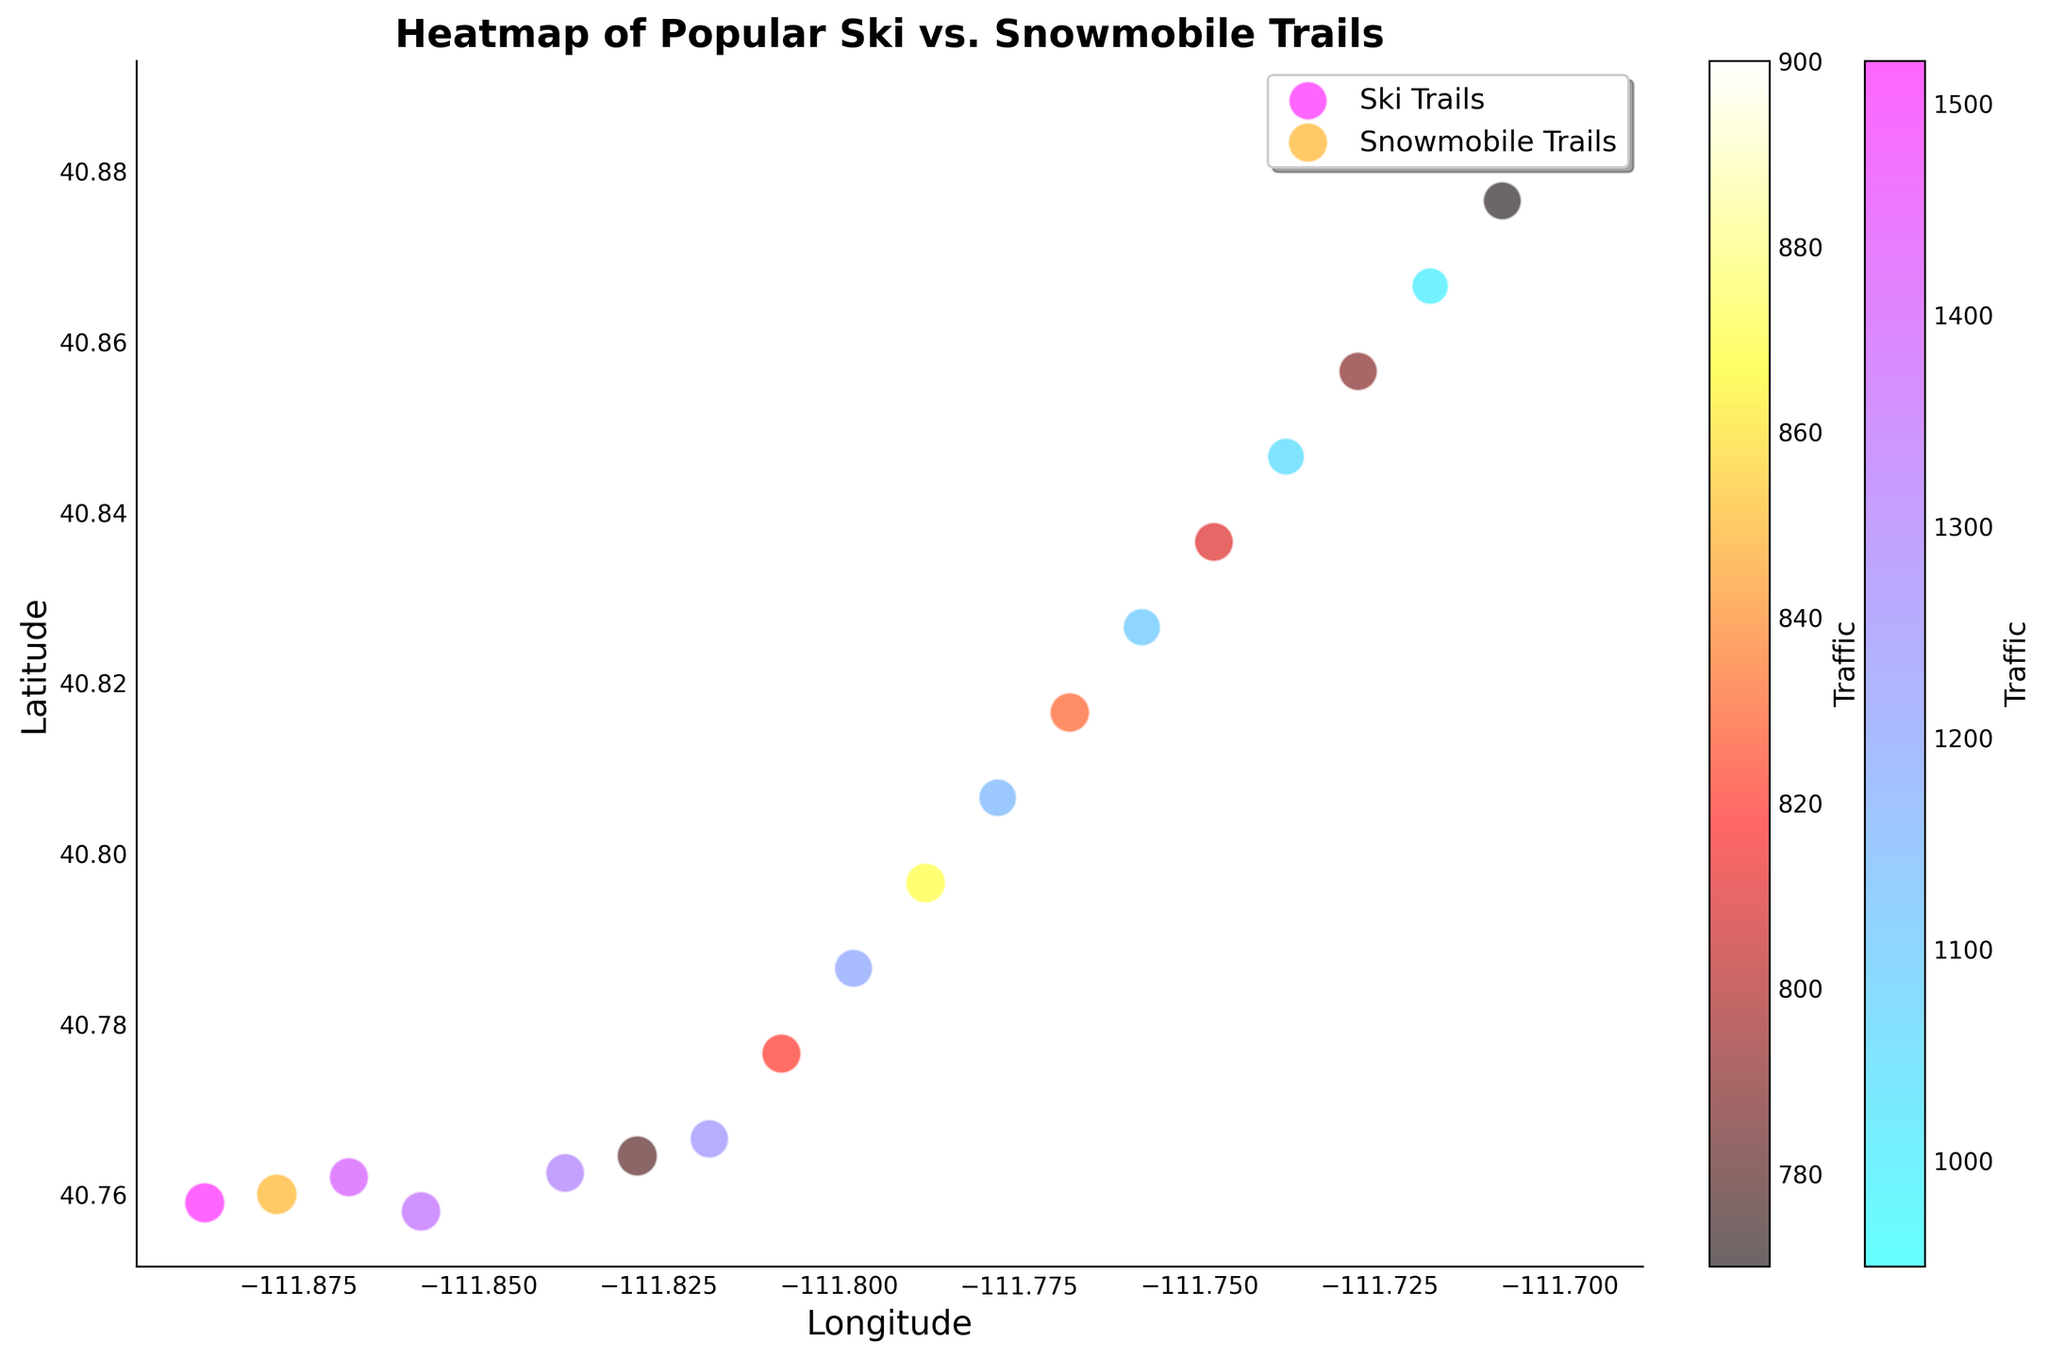What are the trail types found in the figure? By observing the legend in the figure, it's clear that there are two types of trails represented: Ski Trails and Snowmobile Trails.
Answer: Ski Trails and Snowmobile Trails Which trail has the highest traffic? By examining the color intensity on the figure, Alpine Glory stands out with the highest traffic as it is marked by the most intense color in the Ski Trails category.
Answer: Alpine Glory Which type of trail generally shows higher traffic levels? By comparing the relative color intensities of the two trail types, Ski Trails appear to have generally higher traffic levels than Snowmobile Trails.
Answer: Ski Trails Between 'Winter Wonderland' and 'Snow Tiger Trail,' which one has higher elevation and how do their traffic levels compare? 'Winter Wonderland' has an elevation of 2750, while 'Snow Tiger Trail' has an elevation of 2650, making 'Winter Wonderland' higher. In terms of traffic, 'Winter Wonderland' has 1400, while 'Snow Tiger Trail' has 1250, making 'Winter Wonderland' also higher in traffic.
Answer: Winter Wonderland has higher elevation; Winter Wonderland has higher traffic than Snow Tiger Trail What is the average elevation of Snowmobile Trails? To find the average, sum the elevations of all Snowmobile Trails and divide by the number of trails: (2950 + 2850 + 2900 + 2750 + 2850 + 2800 + 2700 + 2650 + 2600)/9 = 2772.
Answer: 2772 Which trail type has more consistent traffic levels based on color variations? By comparing the color consistency between the Ski Trails and Snowmobile Trails, Ski Trails show greater variations in traffic intensity whereas Snowmobile Trails display a more uniform color, indicating more consistent traffic levels.
Answer: Snowmobile Trails Where are the densest clusters for Ski and Snowmobile Trails located in the figure? Looking at the figure, Ski Trails are clustered mainly towards the center-left of the map, while Snowmobile Trails are more dispersed but tend to cluster towards the center-right of the map.
Answer: Ski: center-left, Snowmobile: center-right Do higher elevations correlate with higher traffic for Ski Trails? To determine this, observe the color intensity and circle sizes which correspond to traffic and elevation respectively for Ski Trails. There is no clear correlation as high-traffic trails do not necessarily have higher elevations.
Answer: No clear correlation Which Snowmobile Trail has the lowest traffic, and what is its elevation? By identifying the trail with the least intense color among Snowmobile Trails, 'Icy Wilderness' stands out with the lowest traffic of 770. Its elevation is 2600.
Answer: Icy Wilderness; Elevation: 2600 Compare the traffic levels between 'Alpine Glory' and 'Snowflake Journey.' 'Alpine Glory' has a traffic level of 1520, whereas 'Snowflake Journey' has a traffic level of 1150. Therefore, 'Alpine Glory' has higher traffic than 'Snowflake Journey.'
Answer: Alpine Glory has higher traffic than Snowflake Journey 